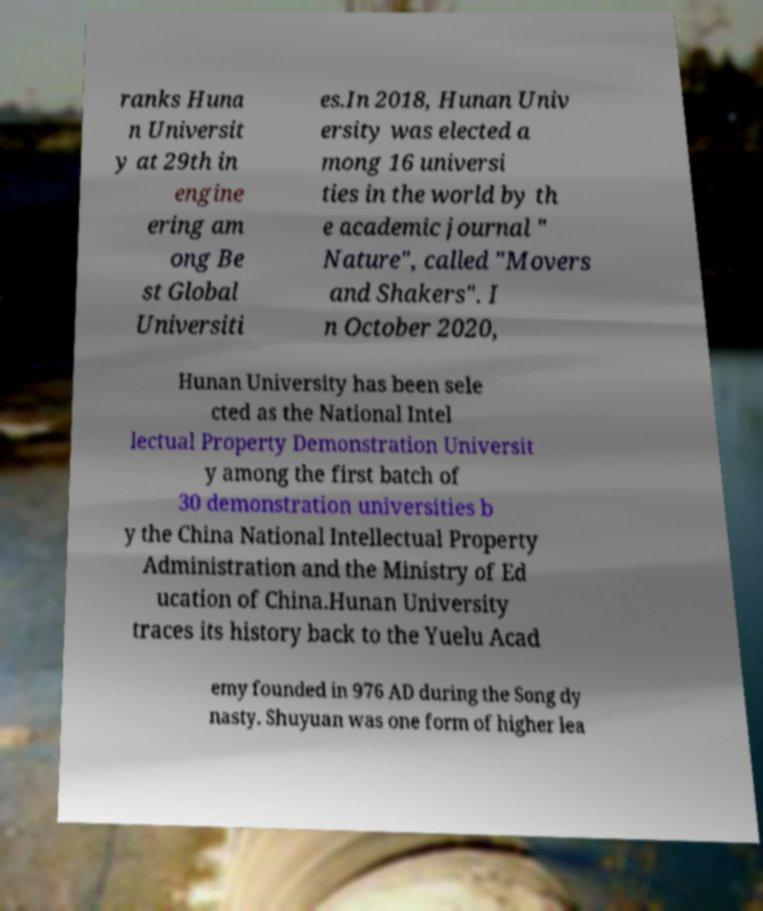There's text embedded in this image that I need extracted. Can you transcribe it verbatim? ranks Huna n Universit y at 29th in engine ering am ong Be st Global Universiti es.In 2018, Hunan Univ ersity was elected a mong 16 universi ties in the world by th e academic journal " Nature", called "Movers and Shakers". I n October 2020, Hunan University has been sele cted as the National Intel lectual Property Demonstration Universit y among the first batch of 30 demonstration universities b y the China National Intellectual Property Administration and the Ministry of Ed ucation of China.Hunan University traces its history back to the Yuelu Acad emy founded in 976 AD during the Song dy nasty. Shuyuan was one form of higher lea 